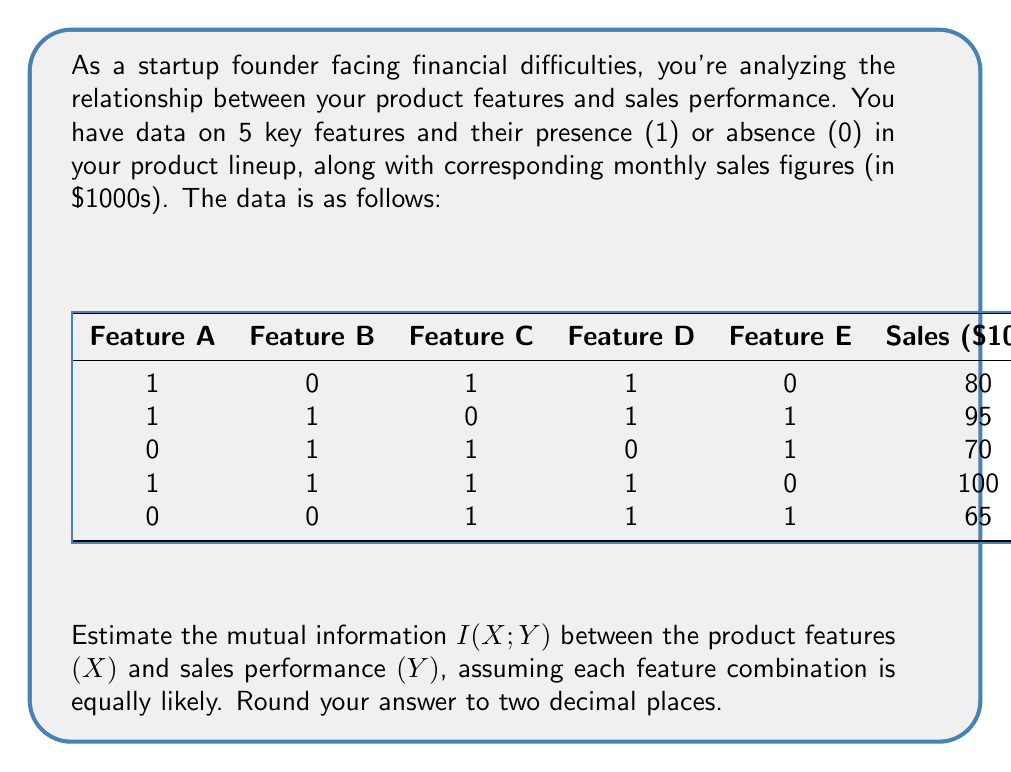Could you help me with this problem? To estimate the mutual information between product features and sales performance, we'll follow these steps:

1) First, we need to calculate the entropy of Y (sales performance), H(Y):
   
   We have 5 different sales values: 65, 70, 80, 95, 100
   Assuming each is equally likely, p(y) = 1/5 for each
   
   $$H(Y) = -\sum p(y) \log_2 p(y) = -5 \cdot \frac{1}{5} \log_2 \frac{1}{5} = \log_2 5 \approx 2.32$$

2) Next, we calculate the conditional entropy H(Y|X):
   
   For each feature combination, we have a single sales value, so H(Y|X=x) = 0 for all x
   
   $$H(Y|X) = \sum p(x) H(Y|X=x) = 0$$

3) The mutual information is given by:
   
   $$I(X;Y) = H(Y) - H(Y|X)$$

4) Substituting the values:
   
   $$I(X;Y) = 2.32 - 0 = 2.32$$

5) Rounding to two decimal places:
   
   $$I(X;Y) \approx 2.32$$

This result suggests that knowing the product features provides about 2.32 bits of information about the sales performance, which is quite significant given that the total entropy of Y is also 2.32 bits.
Answer: $2.32$ bits 